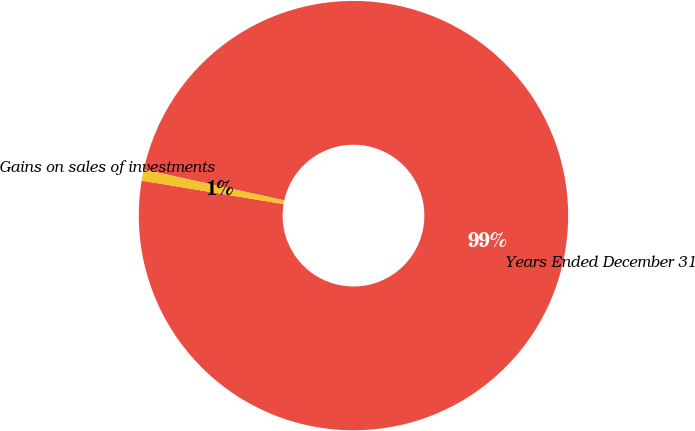Convert chart. <chart><loc_0><loc_0><loc_500><loc_500><pie_chart><fcel>Years Ended December 31<fcel>Gains on sales of investments<nl><fcel>99.16%<fcel>0.84%<nl></chart> 